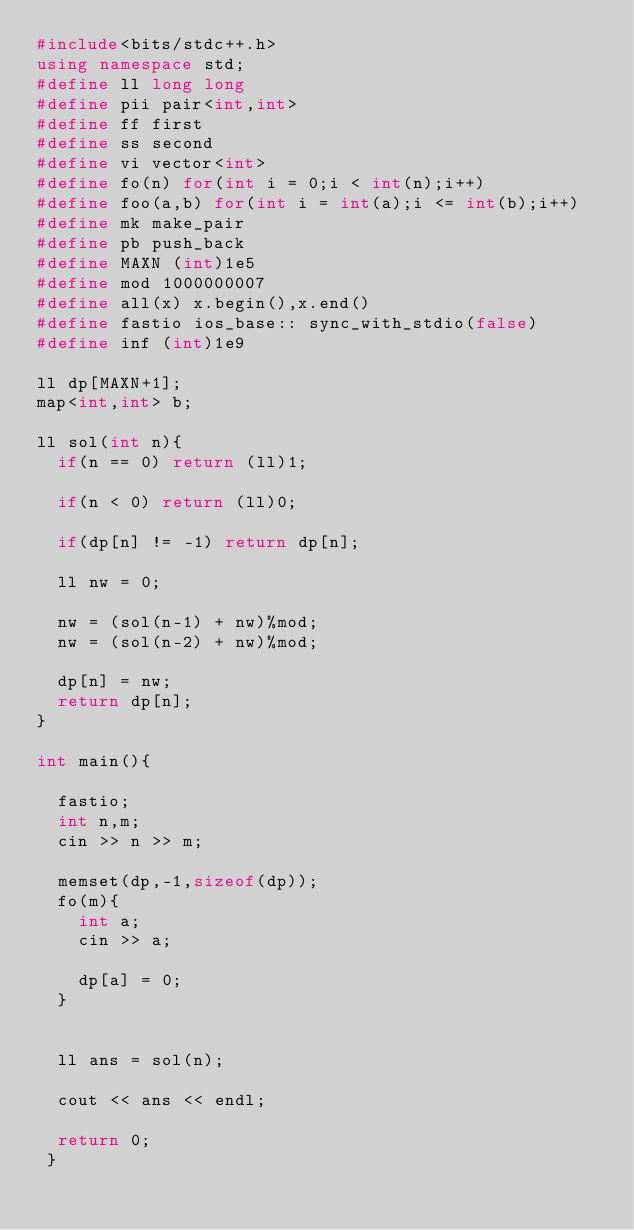<code> <loc_0><loc_0><loc_500><loc_500><_C++_>#include<bits/stdc++.h> 
using namespace std; 
#define ll long long
#define pii pair<int,int>
#define ff first
#define ss second
#define vi vector<int>
#define fo(n) for(int i = 0;i < int(n);i++)
#define foo(a,b) for(int i = int(a);i <= int(b);i++)
#define mk make_pair
#define pb push_back
#define MAXN (int)1e5
#define mod 1000000007
#define all(x) x.begin(),x.end()
#define fastio ios_base:: sync_with_stdio(false)
#define inf (int)1e9

ll dp[MAXN+1];
map<int,int> b;

ll sol(int n){
	if(n == 0) return (ll)1;

	if(n < 0) return (ll)0;

	if(dp[n] != -1) return dp[n];

	ll nw = 0;

	nw = (sol(n-1) + nw)%mod;
	nw = (sol(n-2) + nw)%mod;

	dp[n] = nw;
	return dp[n];
}

int main(){

	fastio;
	int n,m;
	cin >> n >> m;

	memset(dp,-1,sizeof(dp));
	fo(m){
		int a;
		cin >> a;

		dp[a] = 0;
	}


	ll ans = sol(n);

	cout << ans << endl;

	return 0;
 }	</code> 